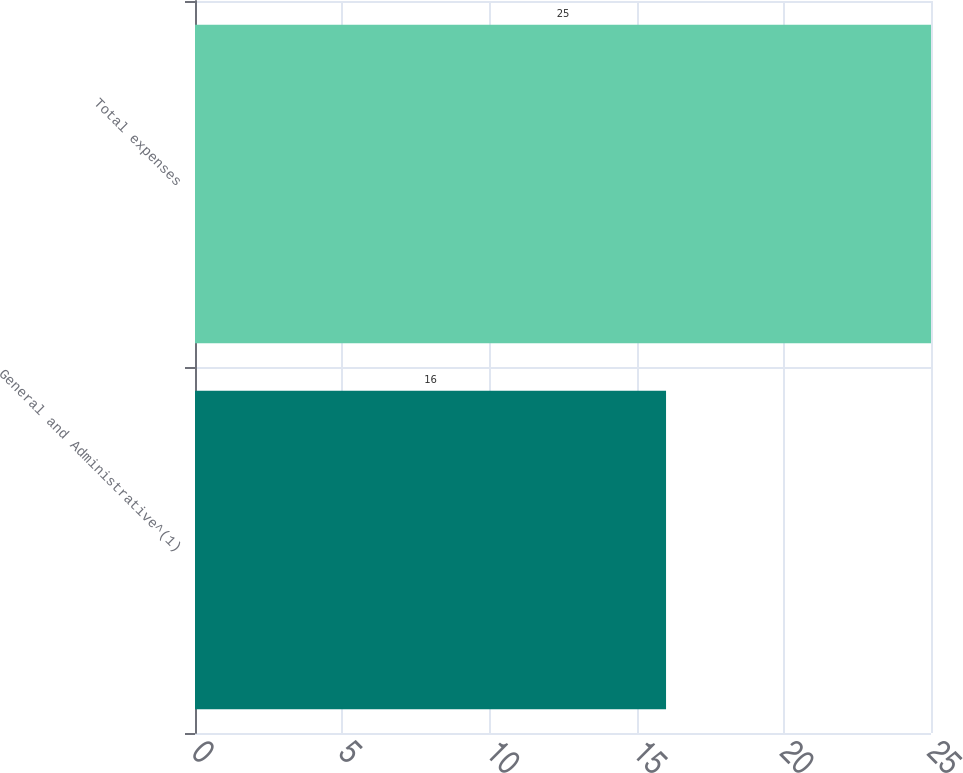<chart> <loc_0><loc_0><loc_500><loc_500><bar_chart><fcel>General and Administrative^(1)<fcel>Total expenses<nl><fcel>16<fcel>25<nl></chart> 